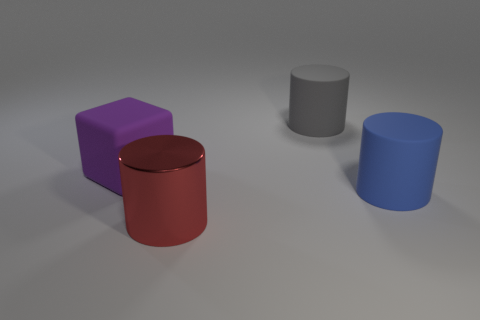What textures do the objects have, and how might they feel to the touch? Based on the image, the purple cube and grey cylinder have a matte texture which suggests they might feel smooth or slightly rough to the touch. The red cylinder has a reflective surface, indicating it might feel smooth and possibly cold like metal or hard plastic. The blue cylinder also has a matte finish, likely giving it a similar touch to the purple cube and grey cylinder. 